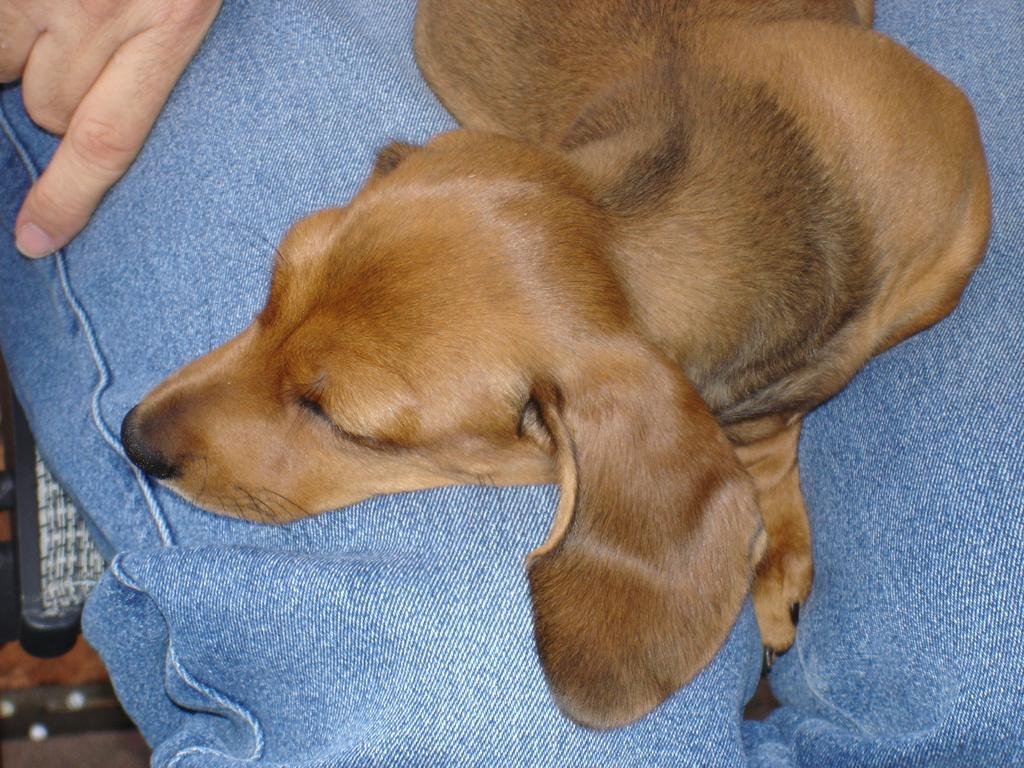What type of animal is present in the image? There is a dog in the image. What is the dog doing in the image? The dog is lying on a person's lap. Where is the person sitting in the image? The person is sitting on a place. What type of rice is being served on the person's skin in the image? There is no rice or mention of skin in the image; it features a dog lying on a person's lap. 